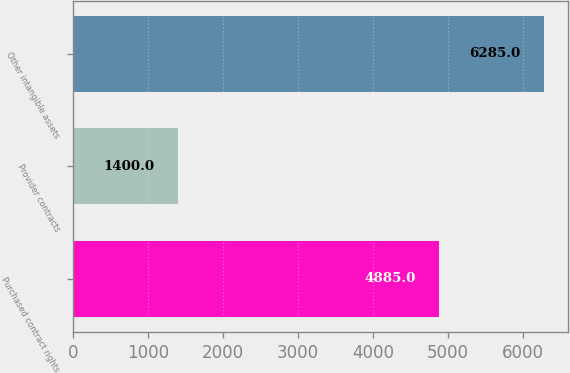Convert chart to OTSL. <chart><loc_0><loc_0><loc_500><loc_500><bar_chart><fcel>Purchased contract rights<fcel>Provider contracts<fcel>Other intangible assets<nl><fcel>4885<fcel>1400<fcel>6285<nl></chart> 